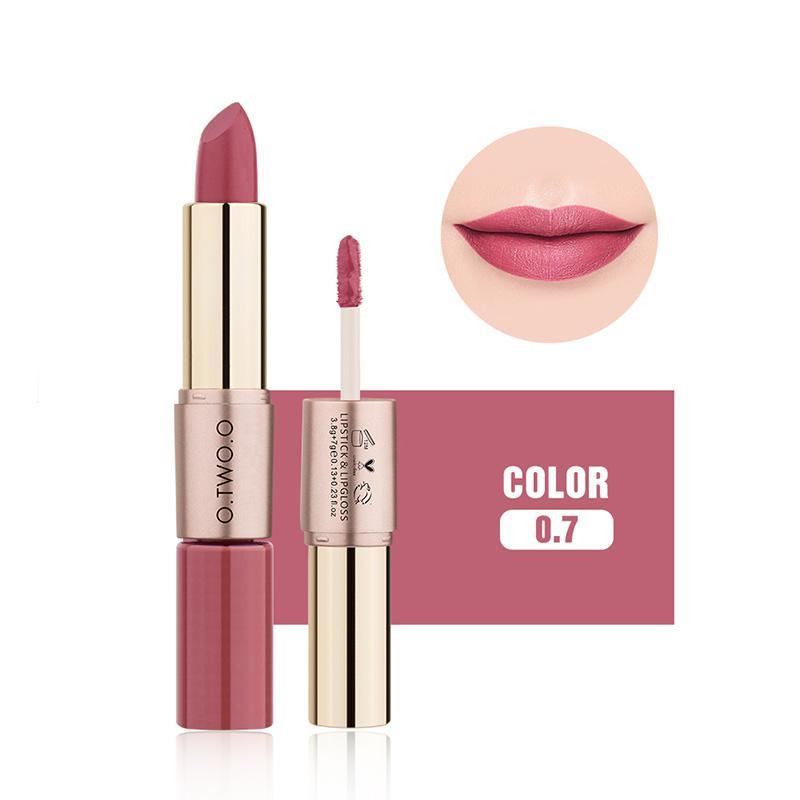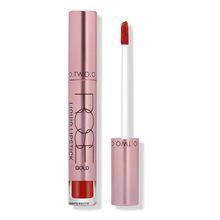The first image is the image on the left, the second image is the image on the right. Considering the images on both sides, is "There are more upright tubes of lipstick in the image on the right." valid? Answer yes or no. No. 